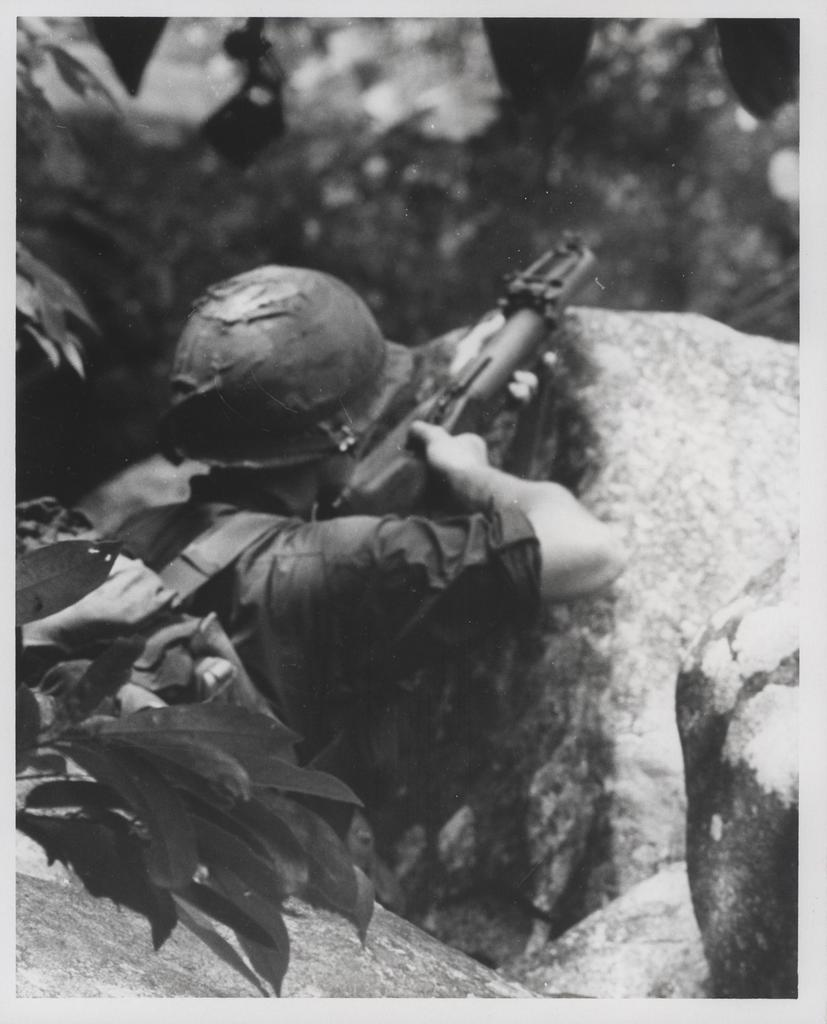What is the main subject of the image? There is a man in the image. What is the man wearing? The man is wearing a bag. What is the man holding in his hand? The man is holding a helmet. What else is the man holding? The man is holding an object. What type of natural features can be seen in the image? There are rocks, plants, and trees visible in the image. What shape is the mine in the image? There is no mine present in the image. What activity is taking place during the recess in the image? There is no recess or any indication of an activity taking place in the image. 